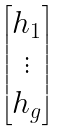Convert formula to latex. <formula><loc_0><loc_0><loc_500><loc_500>\begin{bmatrix} h _ { 1 } \\ \vdots \\ h _ { g } \end{bmatrix}</formula> 